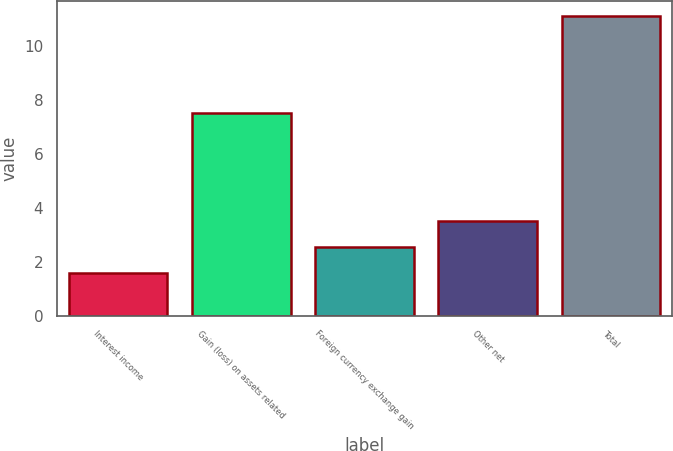<chart> <loc_0><loc_0><loc_500><loc_500><bar_chart><fcel>Interest income<fcel>Gain (loss) on assets related<fcel>Foreign currency exchange gain<fcel>Other net<fcel>Total<nl><fcel>1.6<fcel>7.5<fcel>2.55<fcel>3.5<fcel>11.1<nl></chart> 